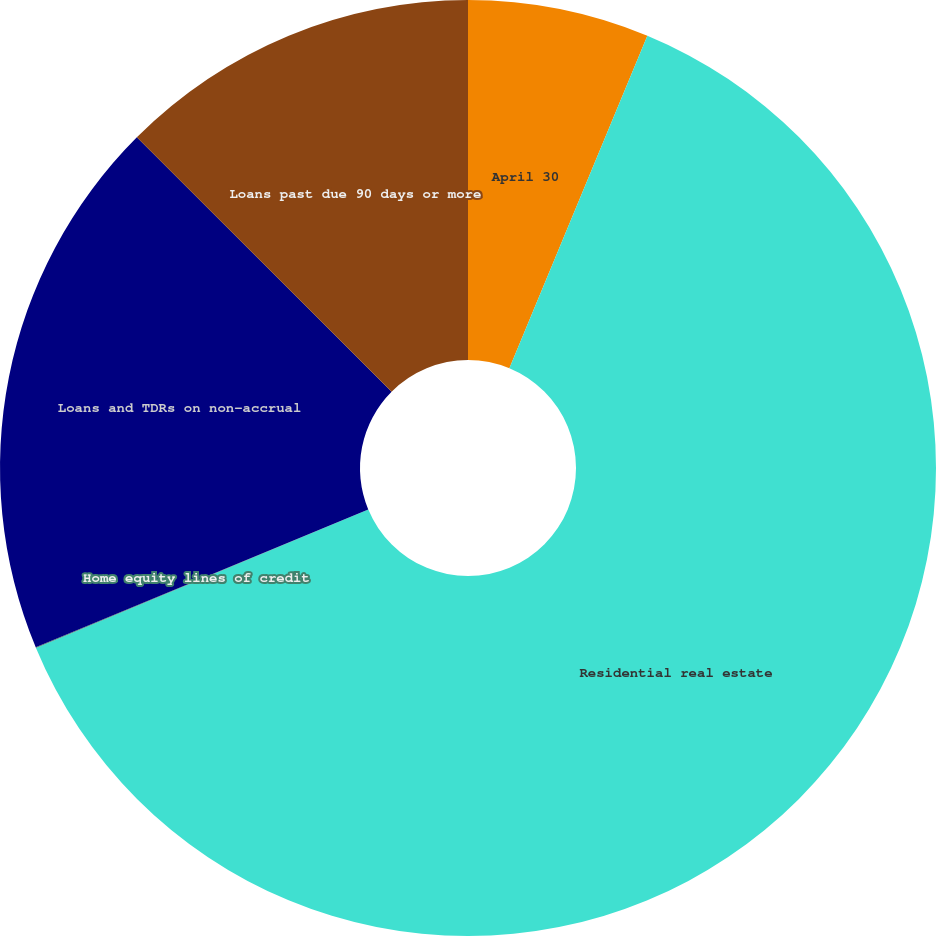Convert chart. <chart><loc_0><loc_0><loc_500><loc_500><pie_chart><fcel>April 30<fcel>Residential real estate<fcel>Home equity lines of credit<fcel>Loans and TDRs on non-accrual<fcel>Loans past due 90 days or more<nl><fcel>6.26%<fcel>62.46%<fcel>0.02%<fcel>18.75%<fcel>12.51%<nl></chart> 